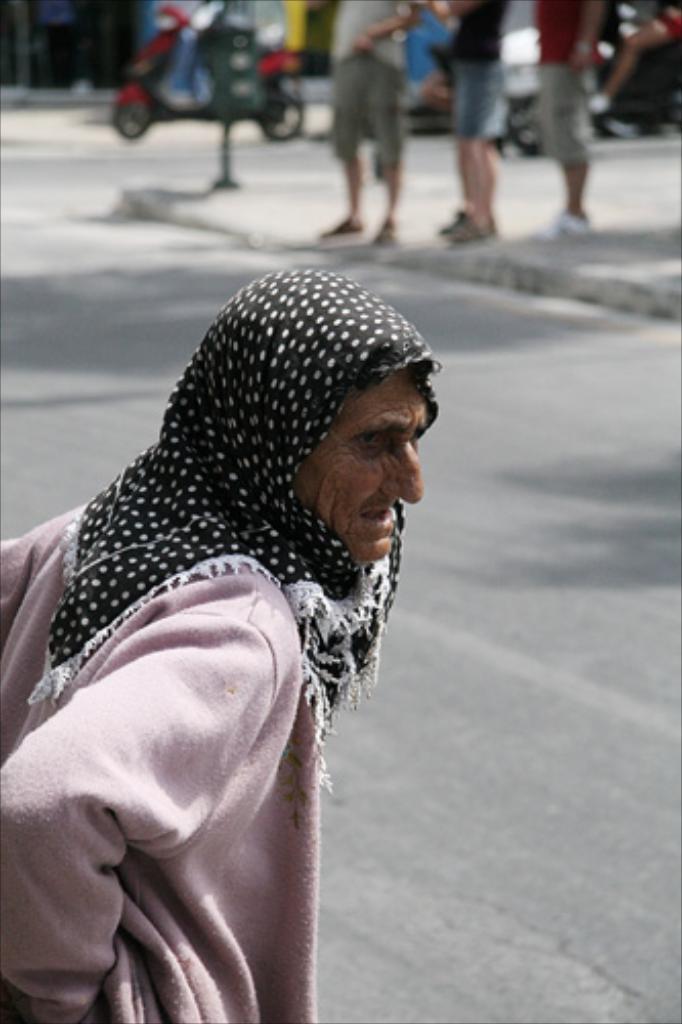Can you describe this image briefly? In this image, on the left there is a person wearing a jacket, scarf. At the top there are people, vehicles, pole, road. 